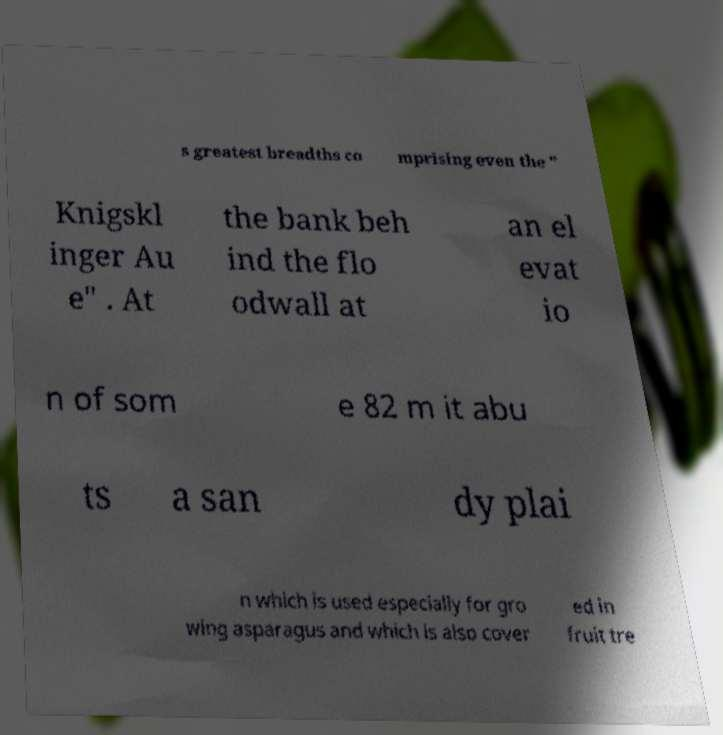For documentation purposes, I need the text within this image transcribed. Could you provide that? s greatest breadths co mprising even the " Knigskl inger Au e" . At the bank beh ind the flo odwall at an el evat io n of som e 82 m it abu ts a san dy plai n which is used especially for gro wing asparagus and which is also cover ed in fruit tre 